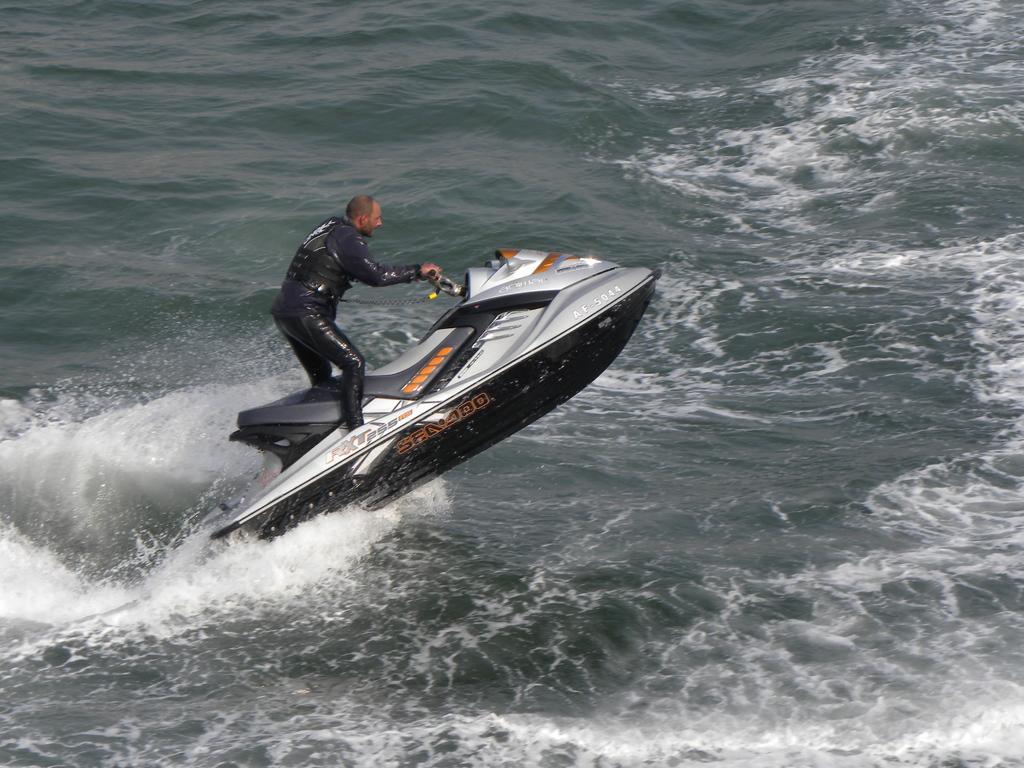Please provide a concise description of this image. In this picture I can see a man riding a jet ski on the water. 